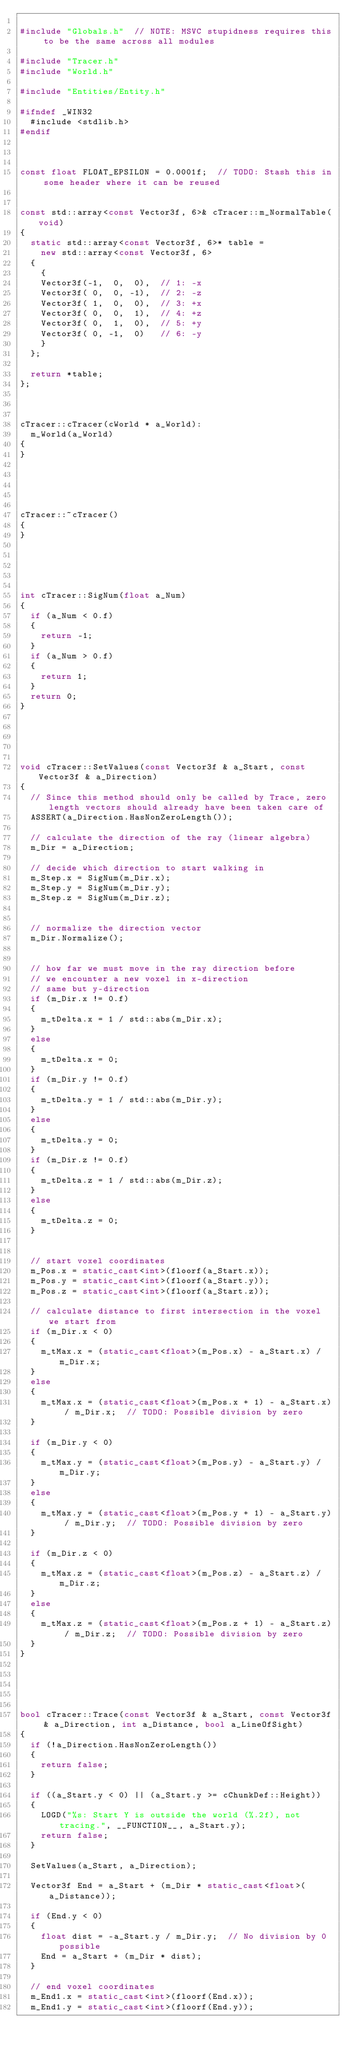<code> <loc_0><loc_0><loc_500><loc_500><_C++_>
#include "Globals.h"  // NOTE: MSVC stupidness requires this to be the same across all modules

#include "Tracer.h"
#include "World.h"

#include "Entities/Entity.h"

#ifndef _WIN32
	#include <stdlib.h>
#endif



const float FLOAT_EPSILON = 0.0001f;  // TODO: Stash this in some header where it can be reused


const std::array<const Vector3f, 6>& cTracer::m_NormalTable(void)
{
	static std::array<const Vector3f, 6>* table =
		new std::array<const Vector3f, 6>
	{
		{
		Vector3f(-1,  0,  0),  // 1: -x
		Vector3f( 0,  0, -1),  // 2: -z
		Vector3f( 1,  0,  0),  // 3: +x
		Vector3f( 0,  0,  1),  // 4: +z
		Vector3f( 0,  1,  0),  // 5: +y
		Vector3f( 0, -1,  0)   // 6: -y
		}
	};

	return *table;
};



cTracer::cTracer(cWorld * a_World):
	m_World(a_World)
{
}





cTracer::~cTracer()
{
}





int cTracer::SigNum(float a_Num)
{
	if (a_Num < 0.f)
	{
		return -1;
	}
	if (a_Num > 0.f)
	{
		return 1;
	}
	return 0;
}





void cTracer::SetValues(const Vector3f & a_Start, const Vector3f & a_Direction)
{
	// Since this method should only be called by Trace, zero length vectors should already have been taken care of
	ASSERT(a_Direction.HasNonZeroLength());

	// calculate the direction of the ray (linear algebra)
	m_Dir = a_Direction;

	// decide which direction to start walking in
	m_Step.x = SigNum(m_Dir.x);
	m_Step.y = SigNum(m_Dir.y);
	m_Step.z = SigNum(m_Dir.z);


	// normalize the direction vector
	m_Dir.Normalize();


	// how far we must move in the ray direction before
	// we encounter a new voxel in x-direction
	// same but y-direction
	if (m_Dir.x != 0.f)
	{
		m_tDelta.x = 1 / std::abs(m_Dir.x);
	}
	else
	{
		m_tDelta.x = 0;
	}
	if (m_Dir.y != 0.f)
	{
		m_tDelta.y = 1 / std::abs(m_Dir.y);
	}
	else
	{
		m_tDelta.y = 0;
	}
	if (m_Dir.z != 0.f)
	{
		m_tDelta.z = 1 / std::abs(m_Dir.z);
	}
	else
	{
		m_tDelta.z = 0;
	}


	// start voxel coordinates
	m_Pos.x = static_cast<int>(floorf(a_Start.x));
	m_Pos.y = static_cast<int>(floorf(a_Start.y));
	m_Pos.z = static_cast<int>(floorf(a_Start.z));

	// calculate distance to first intersection in the voxel we start from
	if (m_Dir.x < 0)
	{
		m_tMax.x = (static_cast<float>(m_Pos.x) - a_Start.x) / m_Dir.x;
	}
	else
	{
		m_tMax.x = (static_cast<float>(m_Pos.x + 1) - a_Start.x) / m_Dir.x;  // TODO: Possible division by zero
	}

	if (m_Dir.y < 0)
	{
		m_tMax.y = (static_cast<float>(m_Pos.y) - a_Start.y) / m_Dir.y;
	}
	else
	{
		m_tMax.y = (static_cast<float>(m_Pos.y + 1) - a_Start.y) / m_Dir.y;  // TODO: Possible division by zero
	}

	if (m_Dir.z < 0)
	{
		m_tMax.z = (static_cast<float>(m_Pos.z) - a_Start.z) / m_Dir.z;
	}
	else
	{
		m_tMax.z = (static_cast<float>(m_Pos.z + 1) - a_Start.z) / m_Dir.z;  // TODO: Possible division by zero
	}
}





bool cTracer::Trace(const Vector3f & a_Start, const Vector3f & a_Direction, int a_Distance, bool a_LineOfSight)
{
	if (!a_Direction.HasNonZeroLength())
	{
		return false;
	}

	if ((a_Start.y < 0) || (a_Start.y >= cChunkDef::Height))
	{
		LOGD("%s: Start Y is outside the world (%.2f), not tracing.", __FUNCTION__, a_Start.y);
		return false;
	}

	SetValues(a_Start, a_Direction);

	Vector3f End = a_Start + (m_Dir * static_cast<float>(a_Distance));

	if (End.y < 0)
	{
		float dist = -a_Start.y / m_Dir.y;  // No division by 0 possible
		End = a_Start + (m_Dir * dist);
	}

	// end voxel coordinates
	m_End1.x = static_cast<int>(floorf(End.x));
	m_End1.y = static_cast<int>(floorf(End.y));</code> 